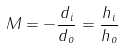Convert formula to latex. <formula><loc_0><loc_0><loc_500><loc_500>M = - { \frac { d _ { i } } { d _ { o } } } = { \frac { h _ { i } } { h _ { o } } }</formula> 